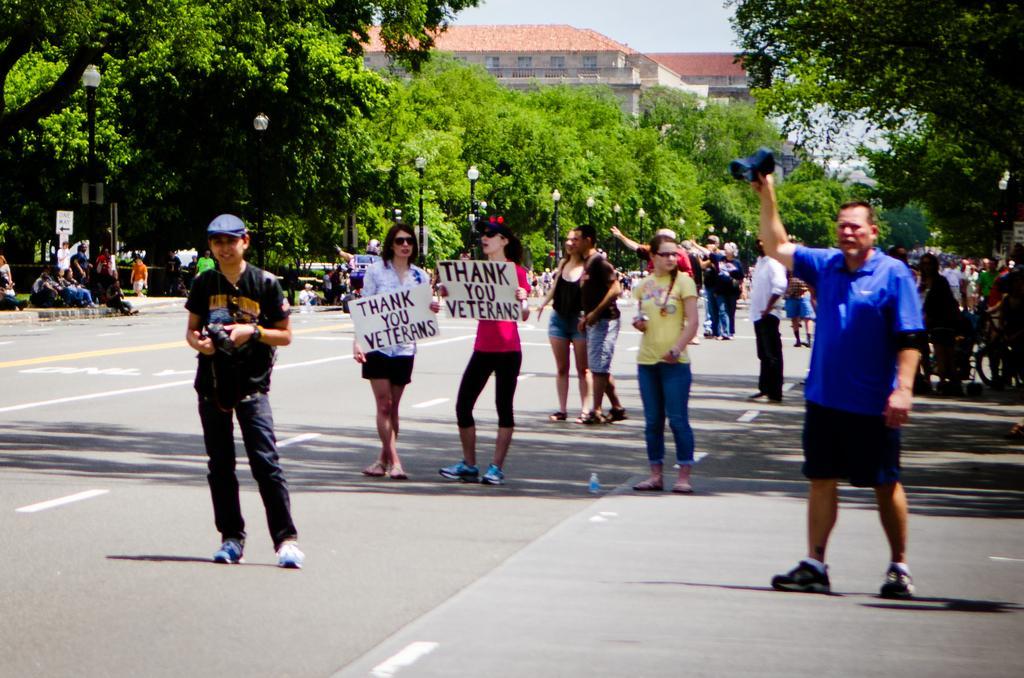In one or two sentences, can you explain what this image depicts? In this image we can see these people holding placards and these people are walking on the road. In the background, we can see light poles, trees, building and the sky. 